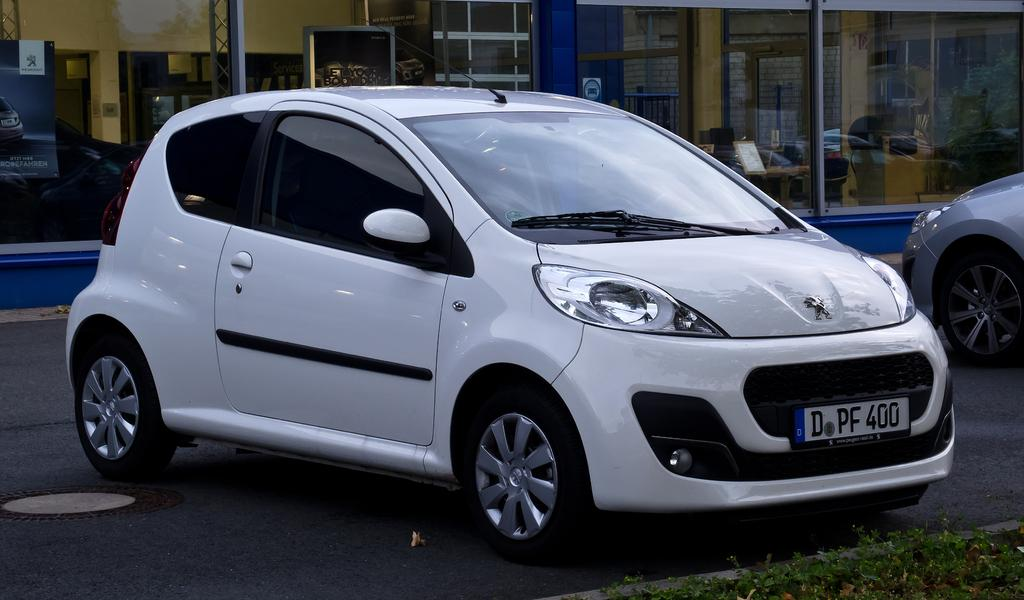What is happening on the road in the image? There are vehicles on the road in the image. What type of vegetation can be seen on the road? There is grass on the road in the image. What can be seen in the background of the image? There is a wall, a poster, and other objects visible in the background of the image. What type of slope can be seen in the image? There is no slope present in the image; it features a road with vehicles and grass. What type of space is visible in the image? The image does not depict any space; it is a ground-level scene with a road, grass, and a background. 